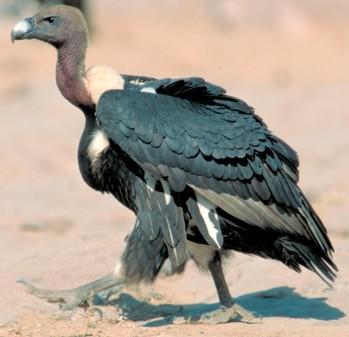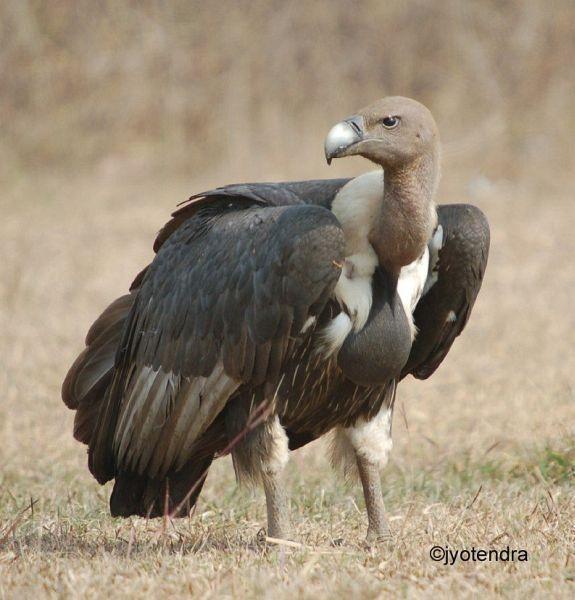The first image is the image on the left, the second image is the image on the right. For the images displayed, is the sentence "An image shows one vulture with outspread wings, but it is not in flight off the ground." factually correct? Answer yes or no. No. The first image is the image on the left, the second image is the image on the right. For the images shown, is this caption "The bird in the left image is looking towards the left." true? Answer yes or no. Yes. 